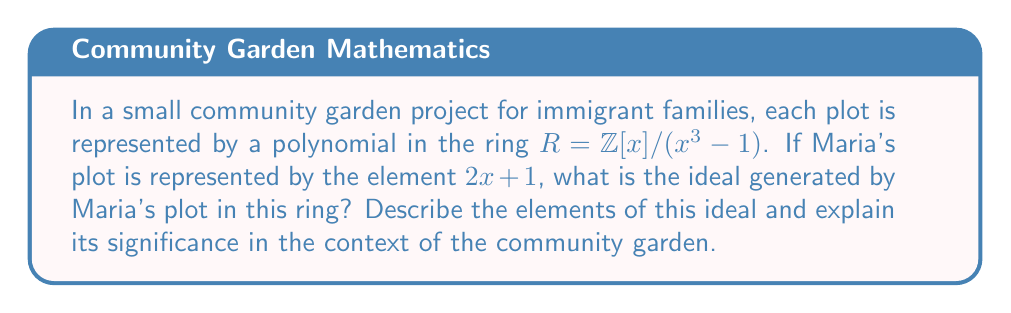Can you answer this question? Let's approach this step-by-step:

1) The ring $R = \mathbb{Z}[x]/(x^3 - 1)$ consists of polynomials of degree at most 2 with integer coefficients, where $x^3 \equiv 1$.

2) The ideal generated by $2x + 1$, denoted as $\langle 2x + 1 \rangle$, consists of all elements in $R$ that can be obtained by multiplying $2x + 1$ by any element of $R$.

3) To find the elements of this ideal, we need to multiply $2x + 1$ by the general element of $R$, which is of the form $ax^2 + bx + c$ where $a, b, c \in \mathbb{Z}$.

4) $(2x + 1)(ax^2 + bx + c) = 2ax^3 + ax^2 + 2bx^2 + bx + 2cx + c$

5) Since $x^3 \equiv 1$ in $R$, this simplifies to:
   $(2a + b)x^2 + (a + 2c)x + (2a + c)$

6) Therefore, the ideal $\langle 2x + 1 \rangle$ consists of all polynomials of the form:
   $(2a + b)x^2 + (a + 2c)x + (2a + c)$ where $a, b, c \in \mathbb{Z}$

7) In the context of the community garden, this ideal represents all possible combinations and multiples of Maria's plot. It symbolizes the potential impact and influence of Maria's gardening efforts within the community.

8) The fact that this ideal includes polynomials with all possible degrees (0, 1, and 2) in $R$ suggests that Maria's plot has a widespread influence in the garden, potentially affecting all aspects of the community project.
Answer: $\langle 2x + 1 \rangle = \{(2a + b)x^2 + (a + 2c)x + (2a + c) : a, b, c \in \mathbb{Z}\}$ 